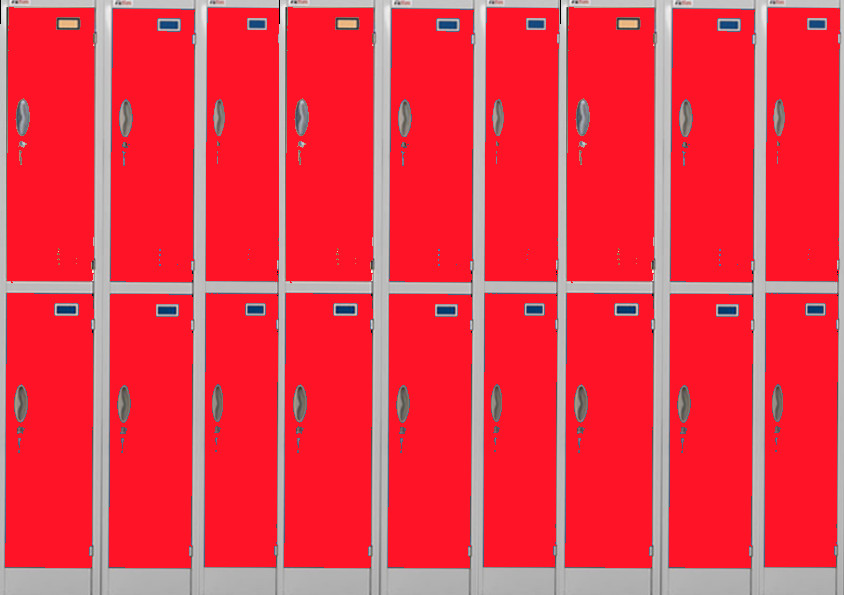Considering the uniformity of the locker design, what could the purpose of the blue stickers or labels be? The blue stickers or labels on the lockers, given their consistent size and placement, likely serve a specific organizational function. They might be used for categorization, helping to quickly identify which lockers belong to certain groups or categories. Alternatively, they could serve as identification markers, potentially indicating the owner or assigned user of each locker. Their systematic and deliberate placement suggests they are an integral part of a broader organization or identification system within this setting. 